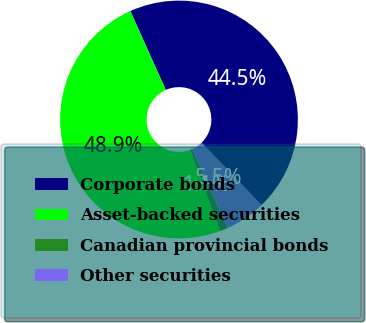Convert chart. <chart><loc_0><loc_0><loc_500><loc_500><pie_chart><fcel>Corporate bonds<fcel>Asset-backed securities<fcel>Canadian provincial bonds<fcel>Other securities<nl><fcel>44.51%<fcel>48.92%<fcel>1.08%<fcel>5.49%<nl></chart> 